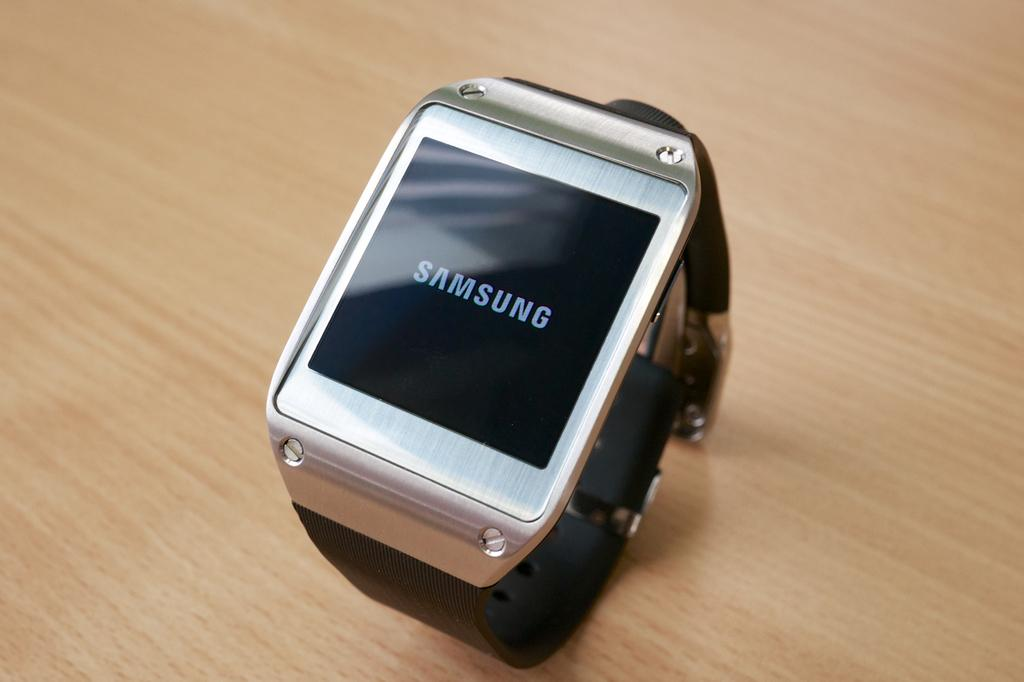Provide a one-sentence caption for the provided image. a Samsung watch with wifi capibilities. 